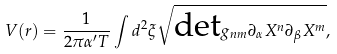<formula> <loc_0><loc_0><loc_500><loc_500>V ( r ) = \frac { 1 } { 2 \pi \alpha ^ { \prime } T } \int d ^ { 2 } \xi \sqrt { \text {det} g _ { n m } \partial _ { \alpha } X ^ { n } \partial _ { \beta } X ^ { m } } ,</formula> 